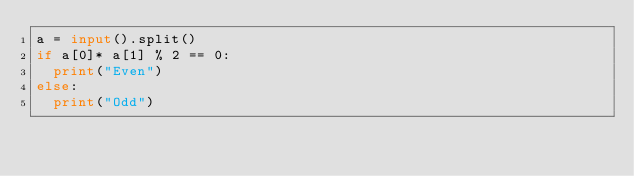Convert code to text. <code><loc_0><loc_0><loc_500><loc_500><_Python_>a = input().split()
if a[0]* a[1] % 2 == 0:
  print("Even")
else:
  print("Odd")</code> 